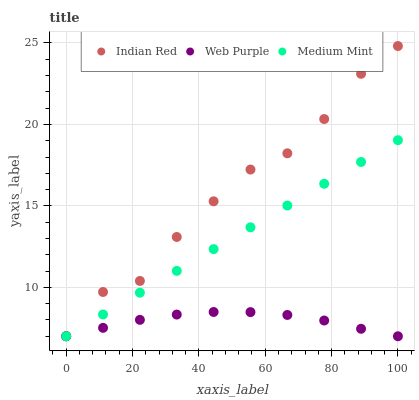Does Web Purple have the minimum area under the curve?
Answer yes or no. Yes. Does Indian Red have the maximum area under the curve?
Answer yes or no. Yes. Does Indian Red have the minimum area under the curve?
Answer yes or no. No. Does Web Purple have the maximum area under the curve?
Answer yes or no. No. Is Medium Mint the smoothest?
Answer yes or no. Yes. Is Indian Red the roughest?
Answer yes or no. Yes. Is Web Purple the smoothest?
Answer yes or no. No. Is Web Purple the roughest?
Answer yes or no. No. Does Medium Mint have the lowest value?
Answer yes or no. Yes. Does Indian Red have the highest value?
Answer yes or no. Yes. Does Web Purple have the highest value?
Answer yes or no. No. Does Web Purple intersect Medium Mint?
Answer yes or no. Yes. Is Web Purple less than Medium Mint?
Answer yes or no. No. Is Web Purple greater than Medium Mint?
Answer yes or no. No. 